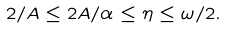<formula> <loc_0><loc_0><loc_500><loc_500>2 / A \leq 2 A / \alpha \leq \eta \leq \omega / 2 .</formula> 